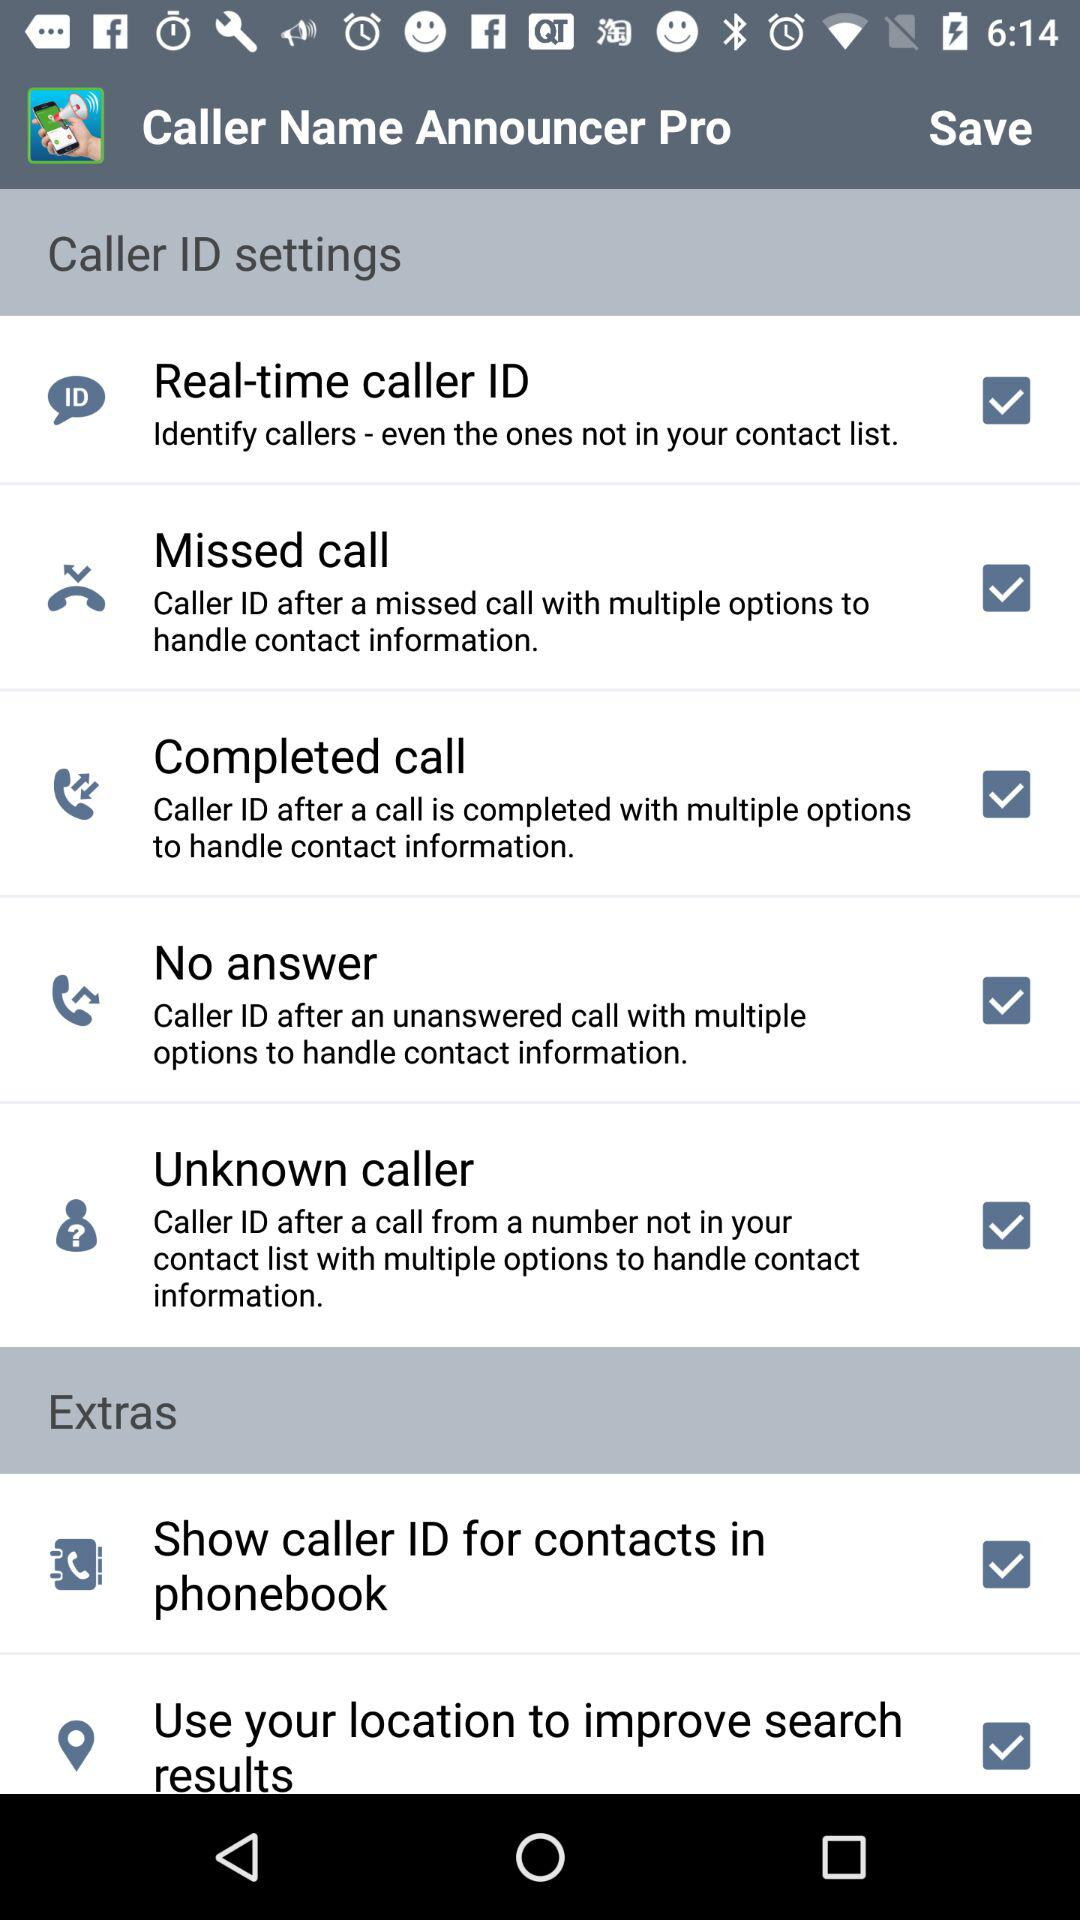What is the status of "Real-time caller ID"? The status is "on". 